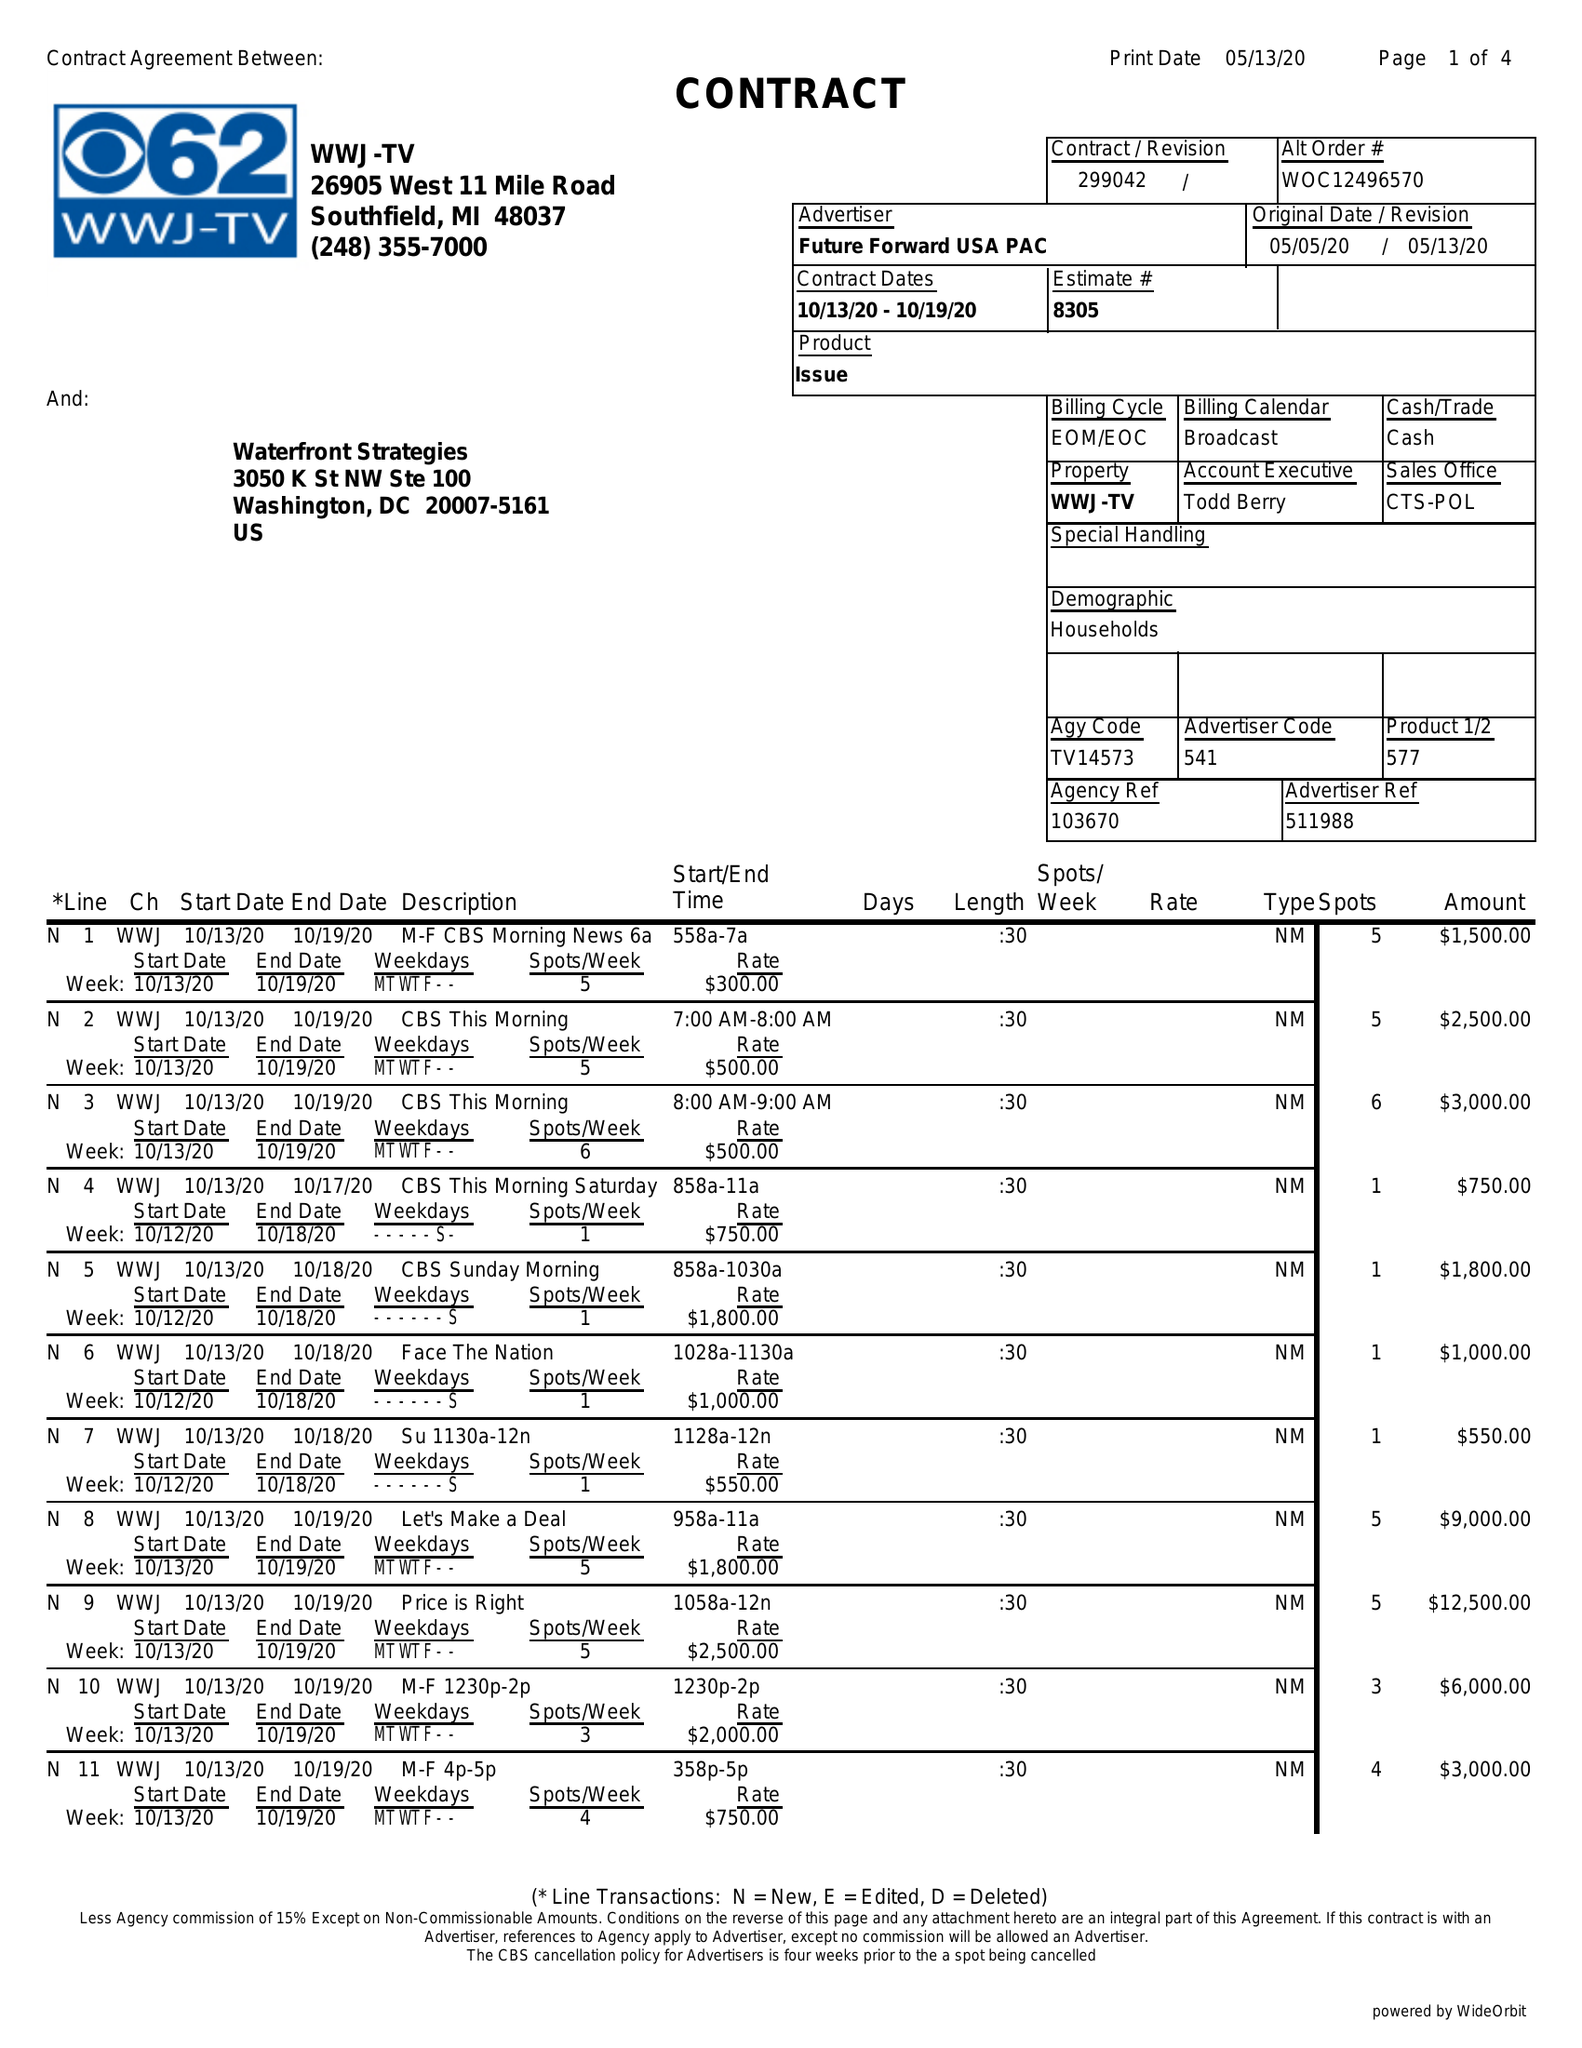What is the value for the contract_num?
Answer the question using a single word or phrase. 299042 